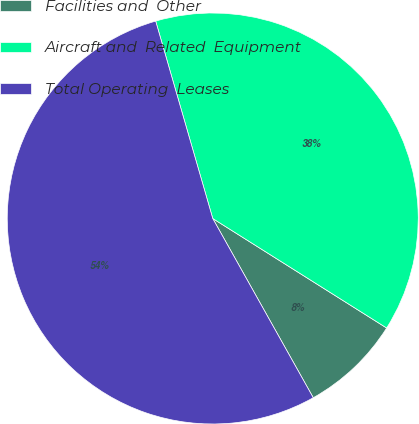Convert chart to OTSL. <chart><loc_0><loc_0><loc_500><loc_500><pie_chart><fcel>Facilities and  Other<fcel>Aircraft and  Related  Equipment<fcel>Total Operating  Leases<nl><fcel>7.92%<fcel>38.42%<fcel>53.65%<nl></chart> 